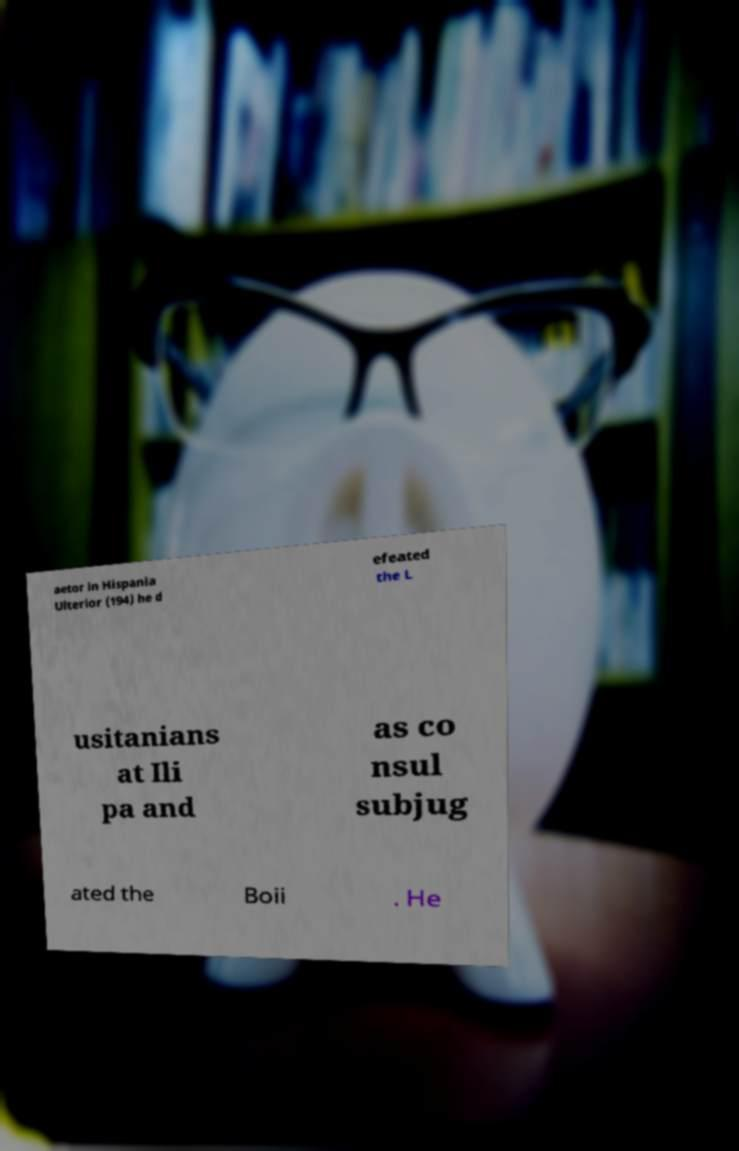Could you extract and type out the text from this image? aetor in Hispania Ulterior (194) he d efeated the L usitanians at Ili pa and as co nsul subjug ated the Boii . He 